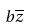<formula> <loc_0><loc_0><loc_500><loc_500>b \overline { z }</formula> 